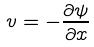Convert formula to latex. <formula><loc_0><loc_0><loc_500><loc_500>v = - \frac { \partial \psi } { \partial x }</formula> 